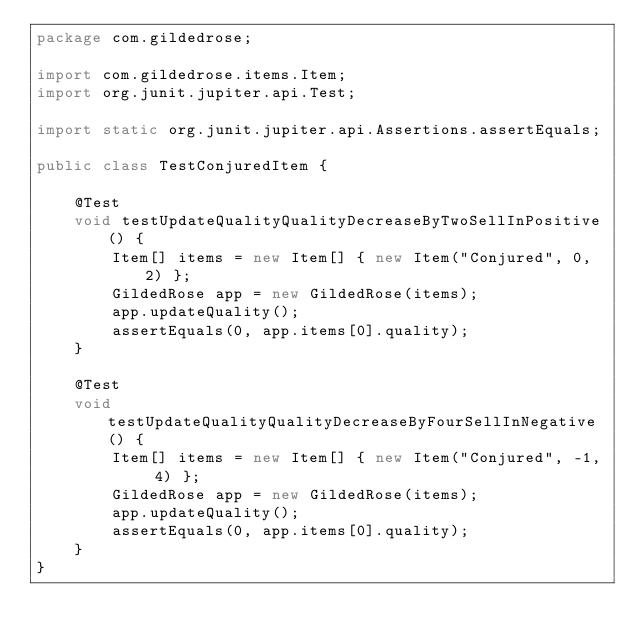Convert code to text. <code><loc_0><loc_0><loc_500><loc_500><_Java_>package com.gildedrose;

import com.gildedrose.items.Item;
import org.junit.jupiter.api.Test;

import static org.junit.jupiter.api.Assertions.assertEquals;

public class TestConjuredItem {

    @Test
    void testUpdateQualityQualityDecreaseByTwoSellInPositive() {
        Item[] items = new Item[] { new Item("Conjured", 0, 2) };
        GildedRose app = new GildedRose(items);
        app.updateQuality();
        assertEquals(0, app.items[0].quality);
    }

    @Test
    void testUpdateQualityQualityDecreaseByFourSellInNegative() {
        Item[] items = new Item[] { new Item("Conjured", -1, 4) };
        GildedRose app = new GildedRose(items);
        app.updateQuality();
        assertEquals(0, app.items[0].quality);
    }
}
</code> 